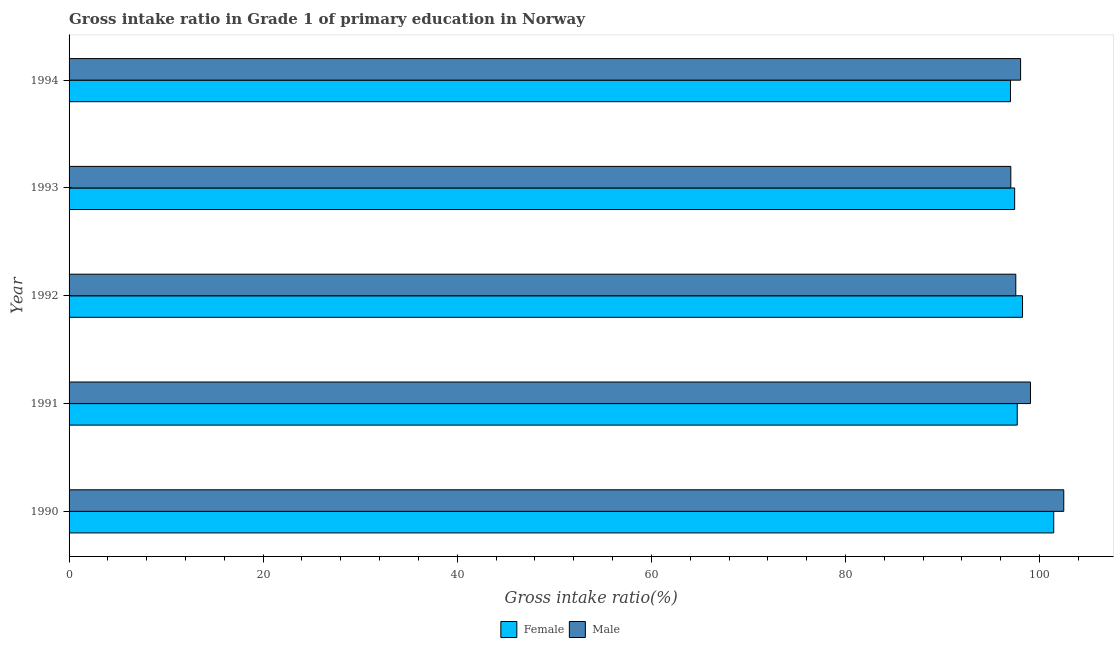How many different coloured bars are there?
Your answer should be very brief. 2. Are the number of bars per tick equal to the number of legend labels?
Your answer should be very brief. Yes. How many bars are there on the 2nd tick from the top?
Offer a very short reply. 2. How many bars are there on the 4th tick from the bottom?
Ensure brevity in your answer.  2. What is the label of the 5th group of bars from the top?
Your response must be concise. 1990. In how many cases, is the number of bars for a given year not equal to the number of legend labels?
Your answer should be very brief. 0. What is the gross intake ratio(female) in 1994?
Provide a short and direct response. 97. Across all years, what is the maximum gross intake ratio(male)?
Provide a short and direct response. 102.49. Across all years, what is the minimum gross intake ratio(female)?
Your answer should be compact. 97. In which year was the gross intake ratio(female) maximum?
Make the answer very short. 1990. In which year was the gross intake ratio(female) minimum?
Provide a succinct answer. 1994. What is the total gross intake ratio(male) in the graph?
Give a very brief answer. 494.19. What is the difference between the gross intake ratio(male) in 1990 and that in 1993?
Your answer should be very brief. 5.46. What is the difference between the gross intake ratio(female) in 1990 and the gross intake ratio(male) in 1993?
Your answer should be very brief. 4.42. What is the average gross intake ratio(female) per year?
Make the answer very short. 98.37. In the year 1993, what is the difference between the gross intake ratio(female) and gross intake ratio(male)?
Provide a short and direct response. 0.4. In how many years, is the gross intake ratio(male) greater than 44 %?
Provide a short and direct response. 5. What is the difference between the highest and the second highest gross intake ratio(female)?
Your answer should be very brief. 3.21. What is the difference between the highest and the lowest gross intake ratio(male)?
Your answer should be very brief. 5.46. In how many years, is the gross intake ratio(female) greater than the average gross intake ratio(female) taken over all years?
Your answer should be compact. 1. Are all the bars in the graph horizontal?
Provide a short and direct response. Yes. What is the difference between two consecutive major ticks on the X-axis?
Give a very brief answer. 20. Does the graph contain any zero values?
Keep it short and to the point. No. Does the graph contain grids?
Offer a terse response. No. How many legend labels are there?
Provide a short and direct response. 2. How are the legend labels stacked?
Provide a short and direct response. Horizontal. What is the title of the graph?
Give a very brief answer. Gross intake ratio in Grade 1 of primary education in Norway. What is the label or title of the X-axis?
Provide a short and direct response. Gross intake ratio(%). What is the label or title of the Y-axis?
Offer a very short reply. Year. What is the Gross intake ratio(%) of Female in 1990?
Your response must be concise. 101.46. What is the Gross intake ratio(%) of Male in 1990?
Your response must be concise. 102.49. What is the Gross intake ratio(%) of Female in 1991?
Provide a succinct answer. 97.7. What is the Gross intake ratio(%) of Male in 1991?
Your response must be concise. 99.06. What is the Gross intake ratio(%) in Female in 1992?
Offer a terse response. 98.24. What is the Gross intake ratio(%) in Male in 1992?
Give a very brief answer. 97.55. What is the Gross intake ratio(%) of Female in 1993?
Offer a terse response. 97.43. What is the Gross intake ratio(%) of Male in 1993?
Offer a very short reply. 97.04. What is the Gross intake ratio(%) in Female in 1994?
Provide a short and direct response. 97. What is the Gross intake ratio(%) in Male in 1994?
Give a very brief answer. 98.04. Across all years, what is the maximum Gross intake ratio(%) in Female?
Offer a terse response. 101.46. Across all years, what is the maximum Gross intake ratio(%) in Male?
Your response must be concise. 102.49. Across all years, what is the minimum Gross intake ratio(%) in Female?
Make the answer very short. 97. Across all years, what is the minimum Gross intake ratio(%) of Male?
Offer a terse response. 97.04. What is the total Gross intake ratio(%) of Female in the graph?
Your answer should be compact. 491.84. What is the total Gross intake ratio(%) of Male in the graph?
Give a very brief answer. 494.19. What is the difference between the Gross intake ratio(%) of Female in 1990 and that in 1991?
Your answer should be compact. 3.76. What is the difference between the Gross intake ratio(%) of Male in 1990 and that in 1991?
Your answer should be very brief. 3.43. What is the difference between the Gross intake ratio(%) of Female in 1990 and that in 1992?
Your answer should be compact. 3.21. What is the difference between the Gross intake ratio(%) of Male in 1990 and that in 1992?
Your response must be concise. 4.94. What is the difference between the Gross intake ratio(%) in Female in 1990 and that in 1993?
Make the answer very short. 4.03. What is the difference between the Gross intake ratio(%) in Male in 1990 and that in 1993?
Make the answer very short. 5.46. What is the difference between the Gross intake ratio(%) of Female in 1990 and that in 1994?
Ensure brevity in your answer.  4.46. What is the difference between the Gross intake ratio(%) of Male in 1990 and that in 1994?
Offer a terse response. 4.45. What is the difference between the Gross intake ratio(%) in Female in 1991 and that in 1992?
Your answer should be compact. -0.55. What is the difference between the Gross intake ratio(%) of Male in 1991 and that in 1992?
Keep it short and to the point. 1.51. What is the difference between the Gross intake ratio(%) of Female in 1991 and that in 1993?
Your answer should be compact. 0.26. What is the difference between the Gross intake ratio(%) in Male in 1991 and that in 1993?
Your response must be concise. 2.03. What is the difference between the Gross intake ratio(%) of Female in 1991 and that in 1994?
Your answer should be very brief. 0.7. What is the difference between the Gross intake ratio(%) of Male in 1991 and that in 1994?
Your answer should be very brief. 1.02. What is the difference between the Gross intake ratio(%) in Female in 1992 and that in 1993?
Offer a very short reply. 0.81. What is the difference between the Gross intake ratio(%) of Male in 1992 and that in 1993?
Offer a very short reply. 0.51. What is the difference between the Gross intake ratio(%) of Female in 1992 and that in 1994?
Your answer should be very brief. 1.24. What is the difference between the Gross intake ratio(%) of Male in 1992 and that in 1994?
Your response must be concise. -0.49. What is the difference between the Gross intake ratio(%) of Female in 1993 and that in 1994?
Give a very brief answer. 0.43. What is the difference between the Gross intake ratio(%) in Male in 1993 and that in 1994?
Make the answer very short. -1.01. What is the difference between the Gross intake ratio(%) of Female in 1990 and the Gross intake ratio(%) of Male in 1991?
Ensure brevity in your answer.  2.4. What is the difference between the Gross intake ratio(%) in Female in 1990 and the Gross intake ratio(%) in Male in 1992?
Provide a succinct answer. 3.91. What is the difference between the Gross intake ratio(%) in Female in 1990 and the Gross intake ratio(%) in Male in 1993?
Ensure brevity in your answer.  4.42. What is the difference between the Gross intake ratio(%) in Female in 1990 and the Gross intake ratio(%) in Male in 1994?
Your response must be concise. 3.41. What is the difference between the Gross intake ratio(%) in Female in 1991 and the Gross intake ratio(%) in Male in 1992?
Give a very brief answer. 0.15. What is the difference between the Gross intake ratio(%) in Female in 1991 and the Gross intake ratio(%) in Male in 1993?
Offer a very short reply. 0.66. What is the difference between the Gross intake ratio(%) in Female in 1991 and the Gross intake ratio(%) in Male in 1994?
Provide a short and direct response. -0.35. What is the difference between the Gross intake ratio(%) of Female in 1992 and the Gross intake ratio(%) of Male in 1993?
Give a very brief answer. 1.21. What is the difference between the Gross intake ratio(%) of Female in 1992 and the Gross intake ratio(%) of Male in 1994?
Ensure brevity in your answer.  0.2. What is the difference between the Gross intake ratio(%) in Female in 1993 and the Gross intake ratio(%) in Male in 1994?
Give a very brief answer. -0.61. What is the average Gross intake ratio(%) of Female per year?
Your response must be concise. 98.37. What is the average Gross intake ratio(%) of Male per year?
Your response must be concise. 98.84. In the year 1990, what is the difference between the Gross intake ratio(%) of Female and Gross intake ratio(%) of Male?
Give a very brief answer. -1.03. In the year 1991, what is the difference between the Gross intake ratio(%) in Female and Gross intake ratio(%) in Male?
Offer a very short reply. -1.37. In the year 1992, what is the difference between the Gross intake ratio(%) in Female and Gross intake ratio(%) in Male?
Your answer should be very brief. 0.69. In the year 1993, what is the difference between the Gross intake ratio(%) in Female and Gross intake ratio(%) in Male?
Offer a terse response. 0.4. In the year 1994, what is the difference between the Gross intake ratio(%) of Female and Gross intake ratio(%) of Male?
Make the answer very short. -1.04. What is the ratio of the Gross intake ratio(%) of Male in 1990 to that in 1991?
Your answer should be very brief. 1.03. What is the ratio of the Gross intake ratio(%) in Female in 1990 to that in 1992?
Make the answer very short. 1.03. What is the ratio of the Gross intake ratio(%) of Male in 1990 to that in 1992?
Your answer should be very brief. 1.05. What is the ratio of the Gross intake ratio(%) of Female in 1990 to that in 1993?
Keep it short and to the point. 1.04. What is the ratio of the Gross intake ratio(%) in Male in 1990 to that in 1993?
Provide a succinct answer. 1.06. What is the ratio of the Gross intake ratio(%) of Female in 1990 to that in 1994?
Provide a succinct answer. 1.05. What is the ratio of the Gross intake ratio(%) in Male in 1990 to that in 1994?
Give a very brief answer. 1.05. What is the ratio of the Gross intake ratio(%) of Female in 1991 to that in 1992?
Give a very brief answer. 0.99. What is the ratio of the Gross intake ratio(%) of Male in 1991 to that in 1992?
Provide a short and direct response. 1.02. What is the ratio of the Gross intake ratio(%) in Male in 1991 to that in 1993?
Offer a terse response. 1.02. What is the ratio of the Gross intake ratio(%) in Male in 1991 to that in 1994?
Give a very brief answer. 1.01. What is the ratio of the Gross intake ratio(%) in Female in 1992 to that in 1993?
Ensure brevity in your answer.  1.01. What is the ratio of the Gross intake ratio(%) in Male in 1992 to that in 1993?
Ensure brevity in your answer.  1.01. What is the ratio of the Gross intake ratio(%) of Female in 1992 to that in 1994?
Provide a short and direct response. 1.01. What is the ratio of the Gross intake ratio(%) in Female in 1993 to that in 1994?
Offer a very short reply. 1. What is the difference between the highest and the second highest Gross intake ratio(%) of Female?
Ensure brevity in your answer.  3.21. What is the difference between the highest and the second highest Gross intake ratio(%) of Male?
Provide a succinct answer. 3.43. What is the difference between the highest and the lowest Gross intake ratio(%) in Female?
Give a very brief answer. 4.46. What is the difference between the highest and the lowest Gross intake ratio(%) of Male?
Your answer should be very brief. 5.46. 